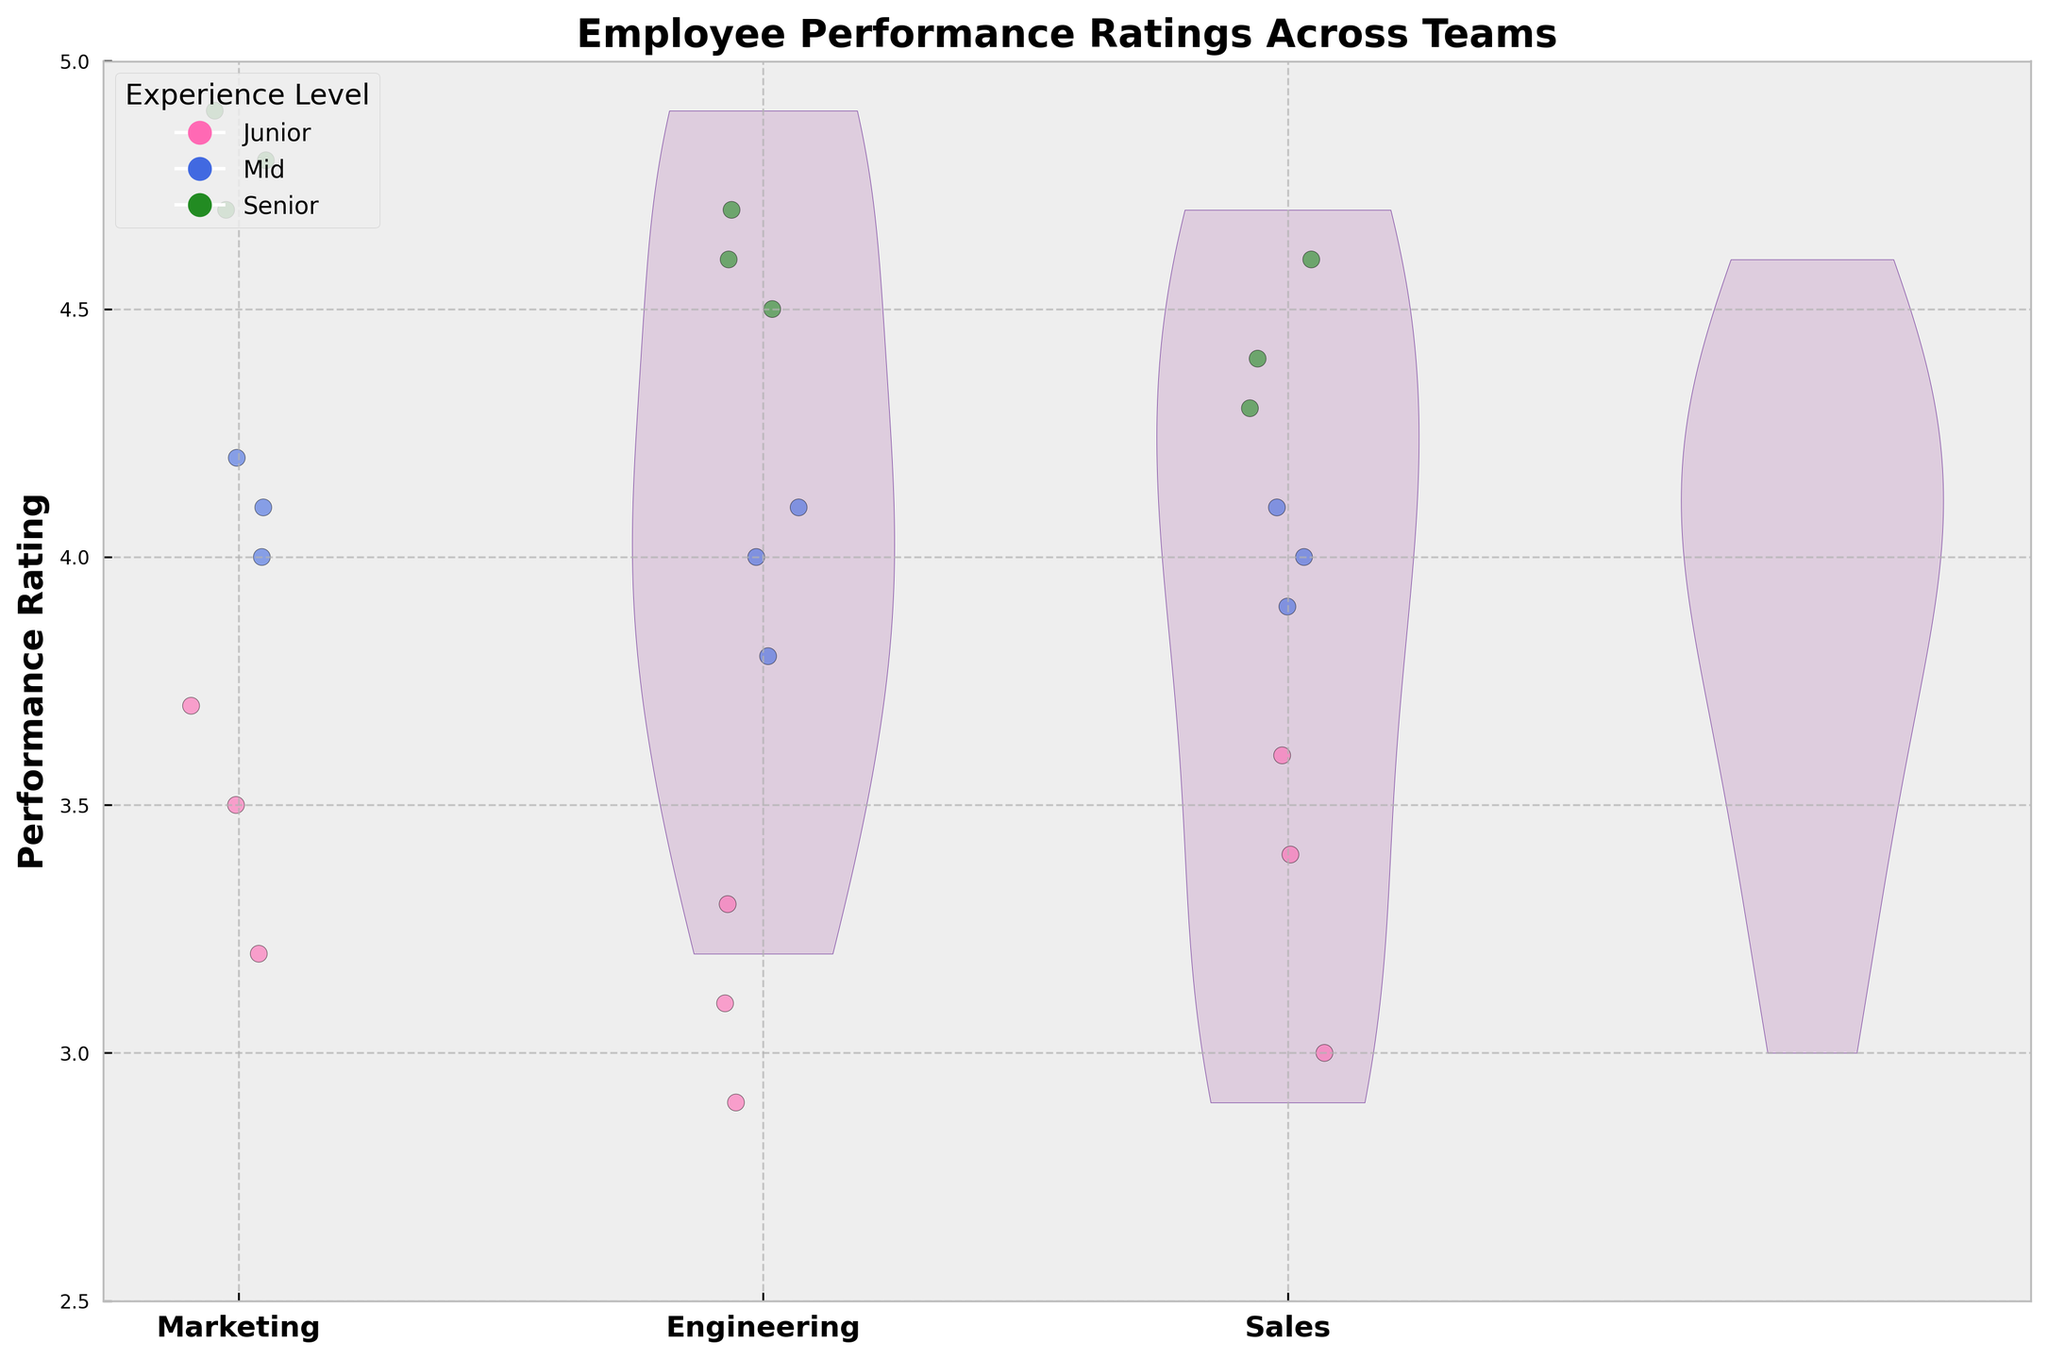What is the title of the figure? Look at the top of the figure where the title is usually placed. The title provides a summary of the plot.
Answer: Employee Performance Ratings Across Teams Which team has the highest median performance rating? Check the general shape and center of the violins. The team with the highest center value has the highest median rating.
Answer: Marketing What is the range of performance ratings for the Sales team? Observe the span of the Sales team's violin plot along the y-axis. The range is from the lowest to the highest rating within the team.
Answer: 3.0 to 4.6 Which experience level is represented by the green jittered points? Refer to the legend on the plot which indicates the color coding for each experience level.
Answer: Senior How do the performance ratings of Junior employees in Engineering compare to those in Marketing? Compare the jittered points for Junior employees in the Engineering and Marketing sections of the plot.
Answer: Engineering Junior ratings are lower What can you say about the variability in ratings among Senior employees in Sales? Analyze the width of the Sales team's violin plot for Senior employees. A wider plot indicates more variability.
Answer: Relatively consistent with slight variability Are ratings for Mid-level employees in the Engineering team more spread out compared to those in the Sales team? Check the width of the violin plots for Mid-level employees in both teams. A wider spread means more variability.
Answer: No, Sales has more spread Which team has the most clustered ratings for Mid-level employees? Look for the violin plot with the least width around the central notes for Mid-level employees.
Answer: Marketing Is there any overlap between the ratings of Junior and Senior employees within the Marketing team? Examine the vertical spread of jittered points of different colors within the Marketing team.
Answer: No significant overlap Which team's employees generally exhibit higher ratings regardless of experience level? Consider the overall height of the violin plots and the positioning of jittered points regardless of experience level.
Answer: Marketing 